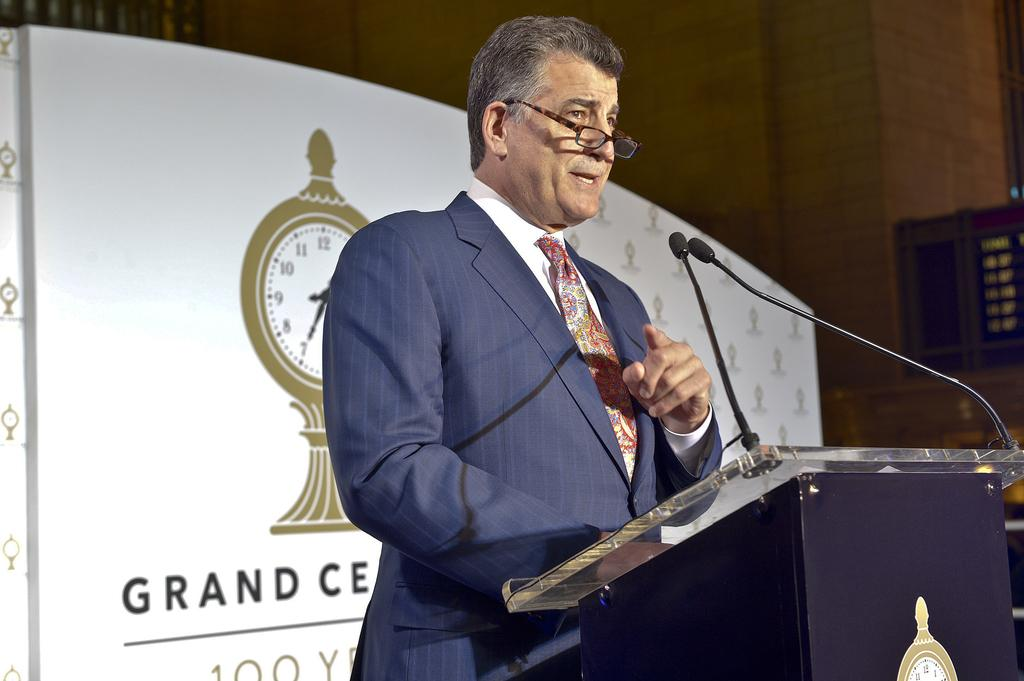Who is the main subject in the image? There is a man in the image. What is the man doing in the image? The man is standing in front of a podium. What is the man wearing in the image? The man is wearing a suit. What objects are present near the man in the image? There are microphones in the image. What can be seen in the background of the image? There is a wall in the background of the image. Can you see any children playing on a playground in the image? There is no playground or children present in the image. Is the man wearing a scarf in the image? The man is not wearing a scarf in the image; he is wearing a suit. 